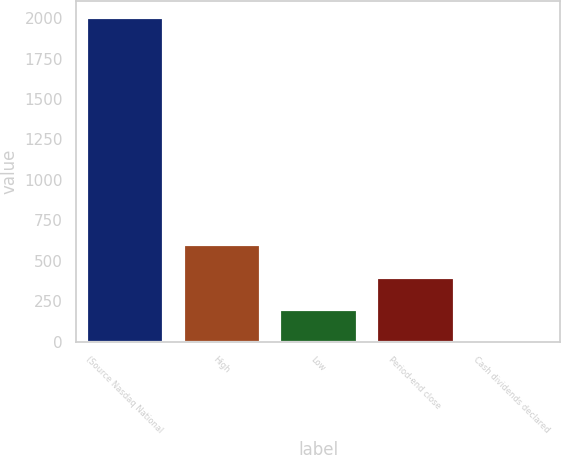Convert chart. <chart><loc_0><loc_0><loc_500><loc_500><bar_chart><fcel>(Source Nasdaq National<fcel>High<fcel>Low<fcel>Period-end close<fcel>Cash dividends declared<nl><fcel>2005<fcel>601.7<fcel>200.76<fcel>401.23<fcel>0.29<nl></chart> 